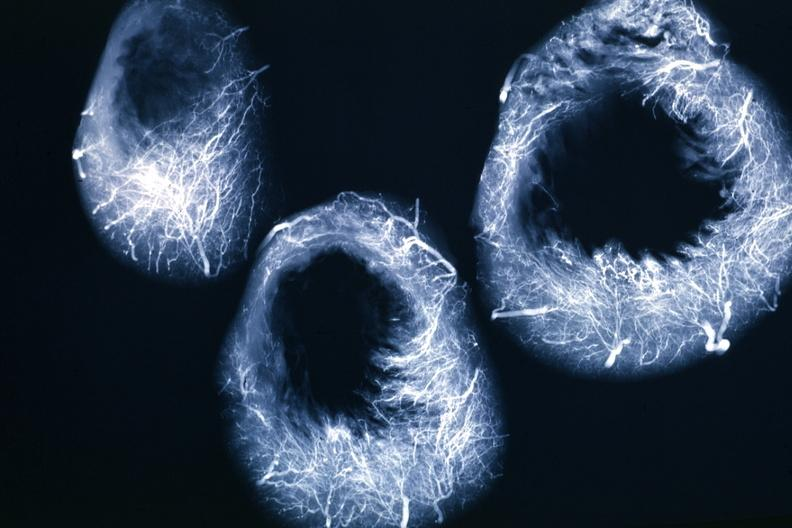does this image show x-ray horizontal sections of ventricle showing penetrating artery distribution quite good?
Answer the question using a single word or phrase. Yes 